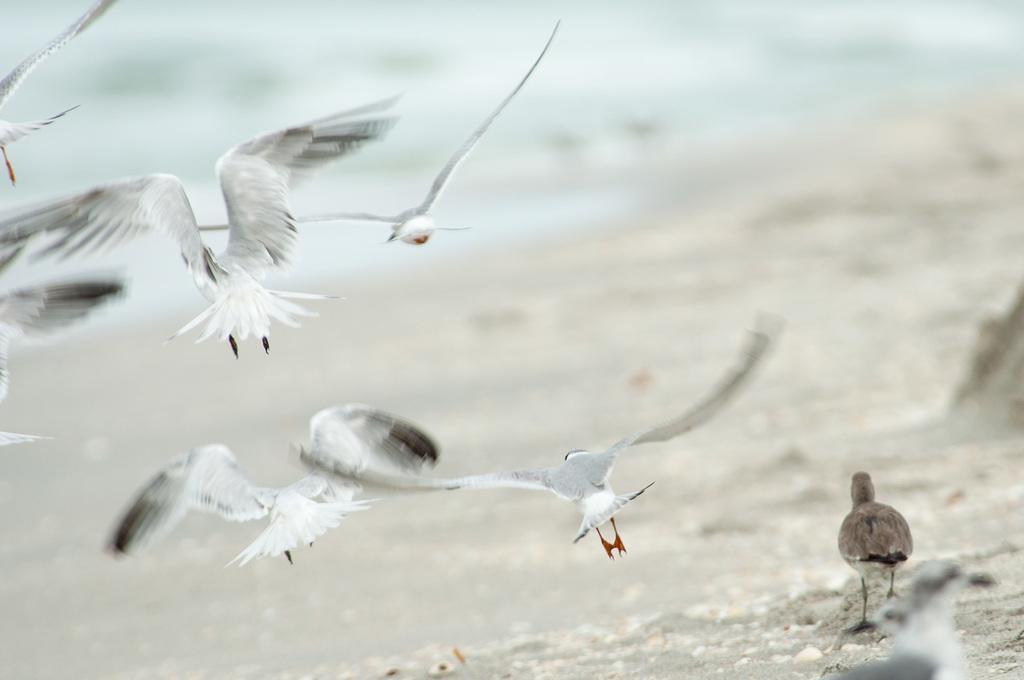How would you summarize this image in a sentence or two? On the right side of the image there are two birds standing on the sand. There are a few birds flying in the air. In the background of the image there is water. 